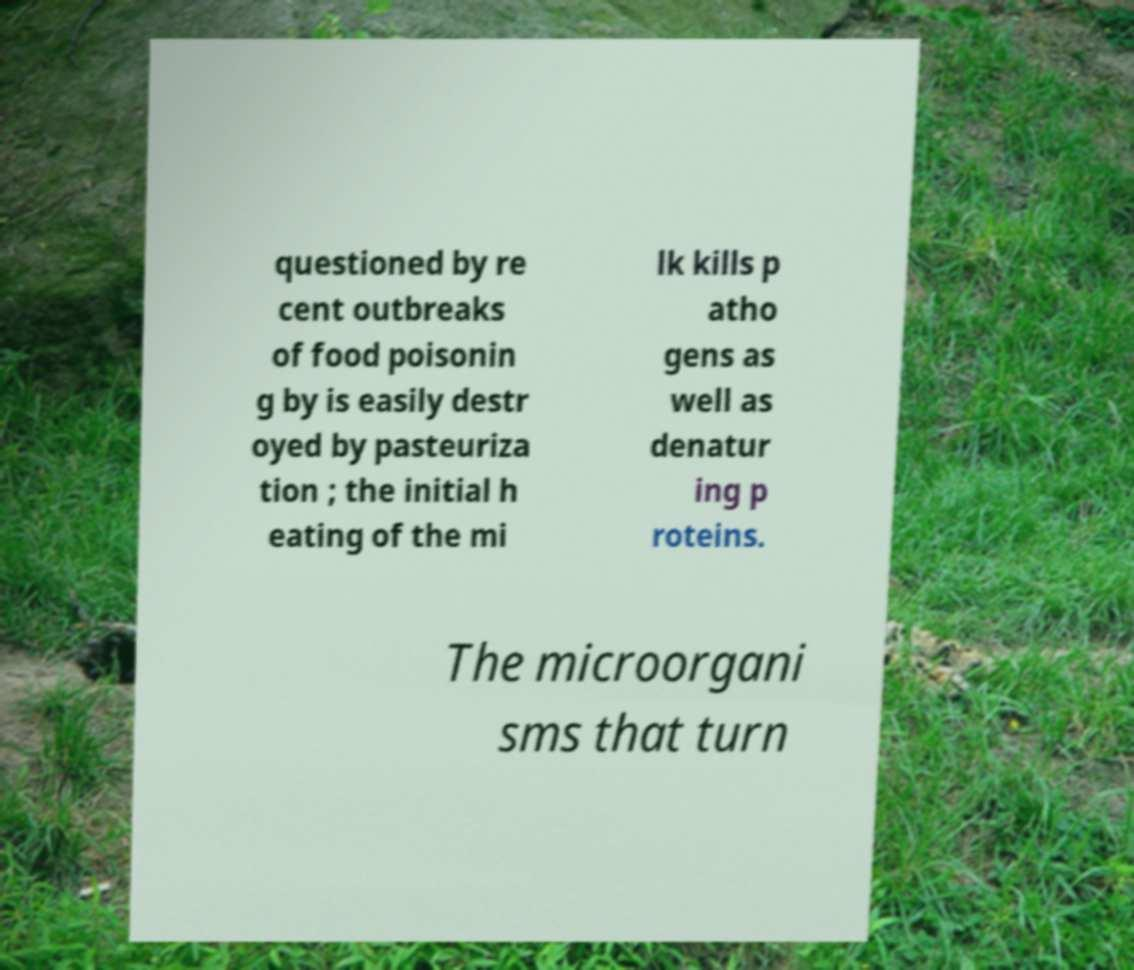Could you extract and type out the text from this image? questioned by re cent outbreaks of food poisonin g by is easily destr oyed by pasteuriza tion ; the initial h eating of the mi lk kills p atho gens as well as denatur ing p roteins. The microorgani sms that turn 